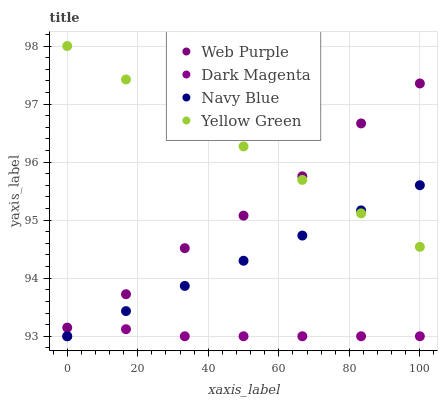Does Dark Magenta have the minimum area under the curve?
Answer yes or no. Yes. Does Yellow Green have the maximum area under the curve?
Answer yes or no. Yes. Does Web Purple have the minimum area under the curve?
Answer yes or no. No. Does Web Purple have the maximum area under the curve?
Answer yes or no. No. Is Yellow Green the smoothest?
Answer yes or no. Yes. Is Web Purple the roughest?
Answer yes or no. Yes. Is Dark Magenta the smoothest?
Answer yes or no. No. Is Dark Magenta the roughest?
Answer yes or no. No. Does Navy Blue have the lowest value?
Answer yes or no. Yes. Does Web Purple have the lowest value?
Answer yes or no. No. Does Yellow Green have the highest value?
Answer yes or no. Yes. Does Web Purple have the highest value?
Answer yes or no. No. Is Dark Magenta less than Web Purple?
Answer yes or no. Yes. Is Yellow Green greater than Dark Magenta?
Answer yes or no. Yes. Does Yellow Green intersect Web Purple?
Answer yes or no. Yes. Is Yellow Green less than Web Purple?
Answer yes or no. No. Is Yellow Green greater than Web Purple?
Answer yes or no. No. Does Dark Magenta intersect Web Purple?
Answer yes or no. No. 